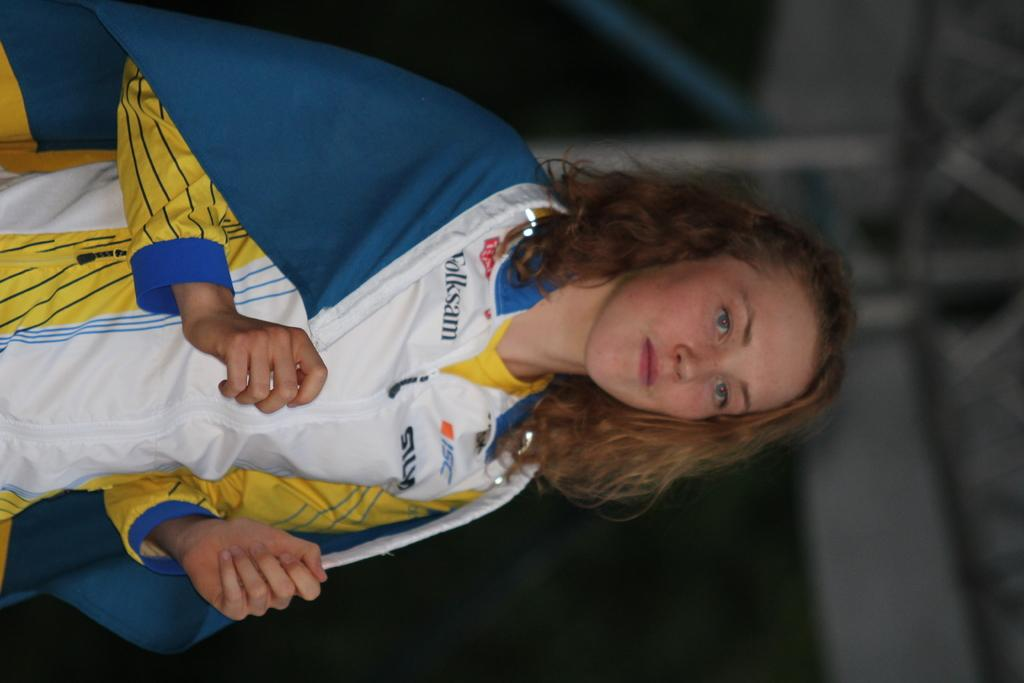<image>
Share a concise interpretation of the image provided. A woman wears a Folksam shirt and has a blanket around her shoulders in this photo. 